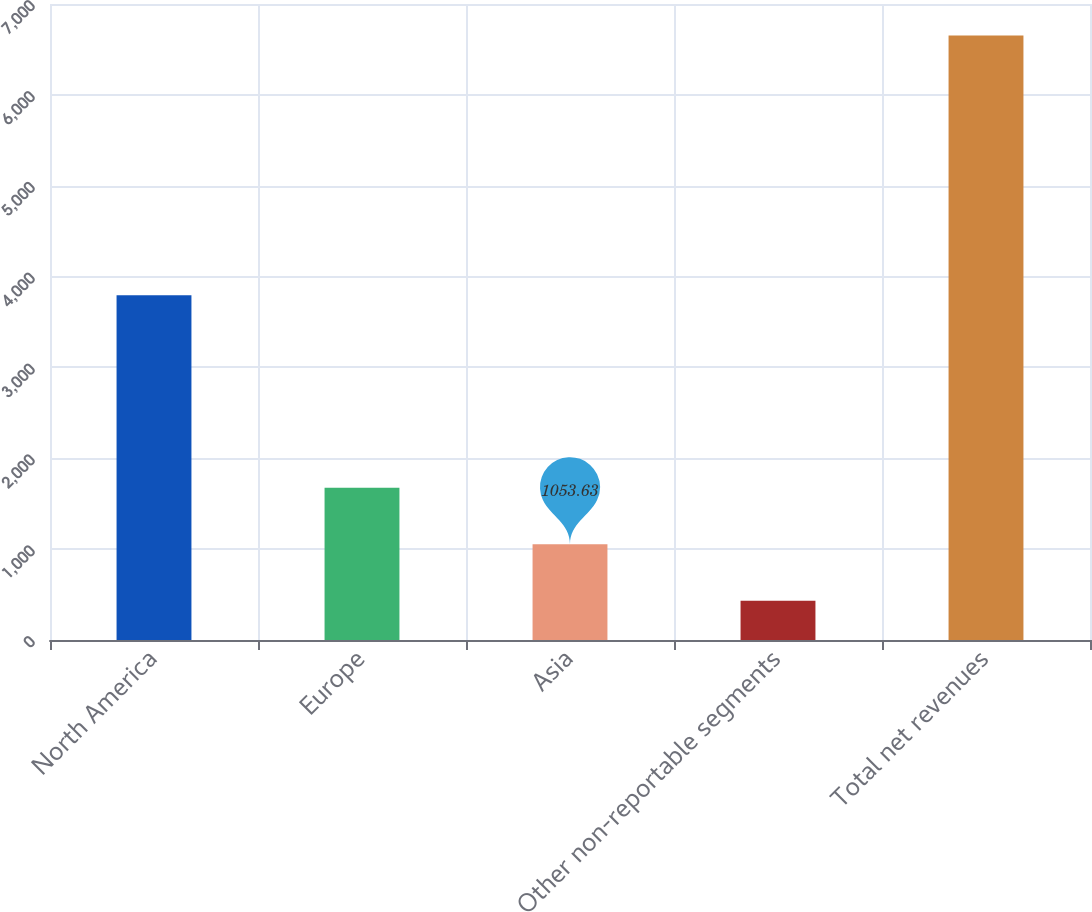Convert chart. <chart><loc_0><loc_0><loc_500><loc_500><bar_chart><fcel>North America<fcel>Europe<fcel>Asia<fcel>Other non-reportable segments<fcel>Total net revenues<nl><fcel>3795<fcel>1675.76<fcel>1053.63<fcel>431.5<fcel>6652.8<nl></chart> 